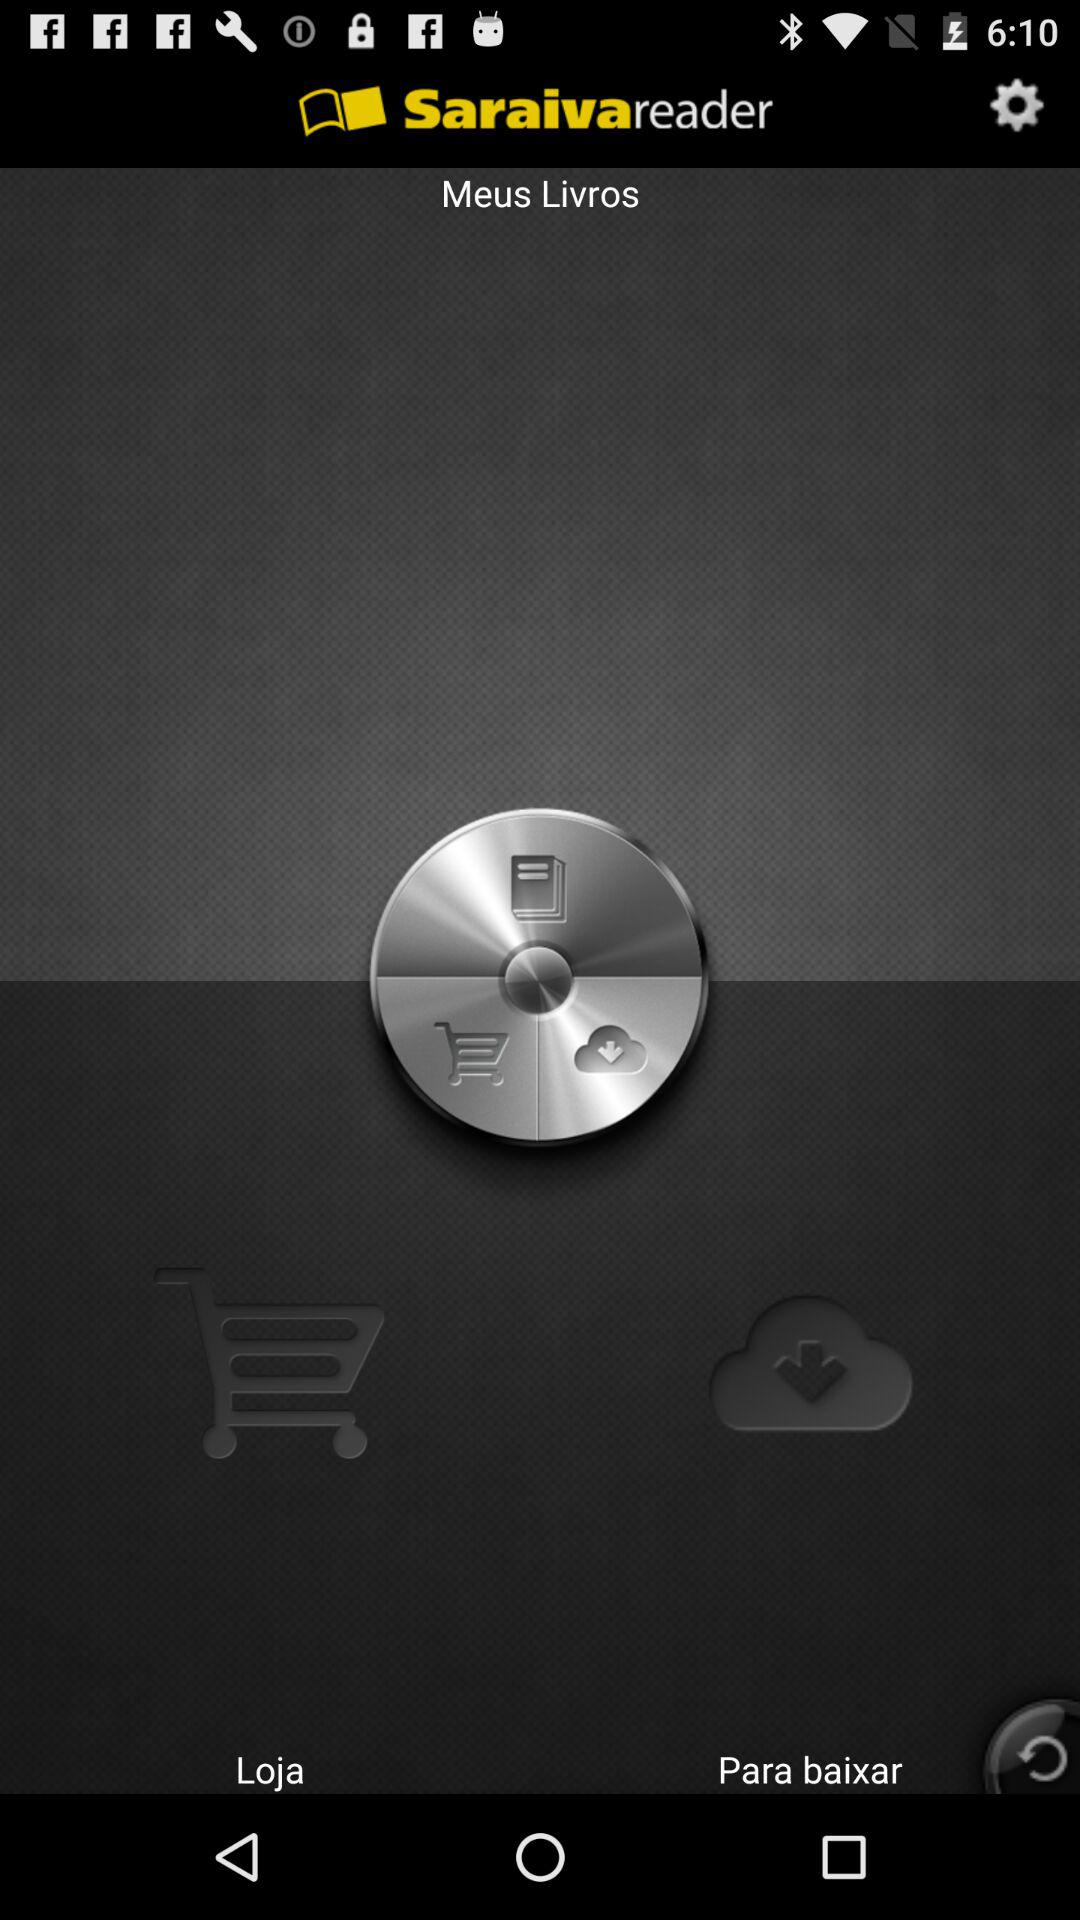What is the application name? The application name is "Saraiva reader". 